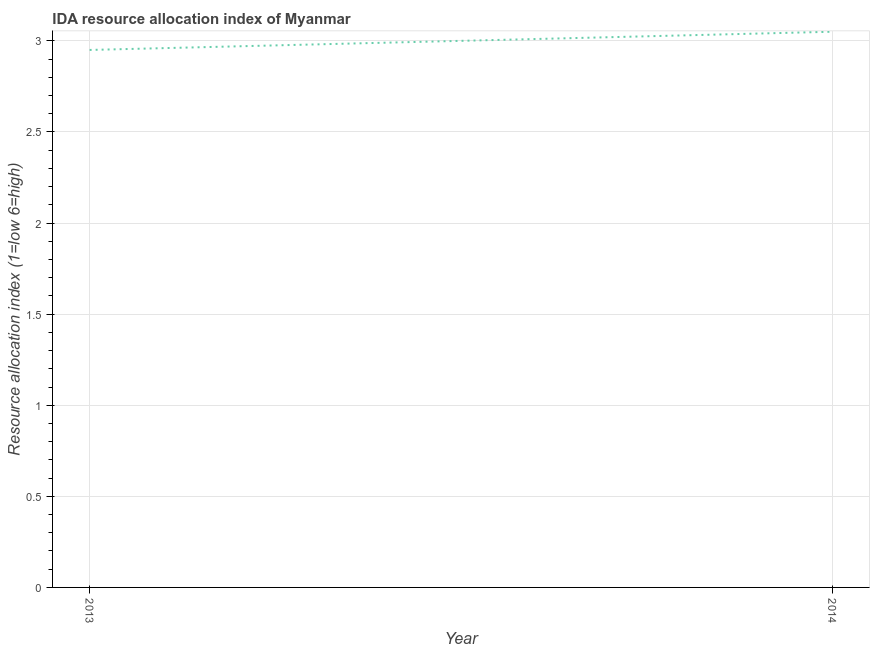What is the ida resource allocation index in 2014?
Ensure brevity in your answer.  3.05. Across all years, what is the maximum ida resource allocation index?
Provide a succinct answer. 3.05. Across all years, what is the minimum ida resource allocation index?
Provide a short and direct response. 2.95. In which year was the ida resource allocation index maximum?
Keep it short and to the point. 2014. What is the sum of the ida resource allocation index?
Your answer should be compact. 6. What is the difference between the ida resource allocation index in 2013 and 2014?
Offer a terse response. -0.1. What is the ratio of the ida resource allocation index in 2013 to that in 2014?
Make the answer very short. 0.97. Is the ida resource allocation index in 2013 less than that in 2014?
Keep it short and to the point. Yes. Does the ida resource allocation index monotonically increase over the years?
Offer a terse response. Yes. How many lines are there?
Make the answer very short. 1. How many years are there in the graph?
Give a very brief answer. 2. What is the difference between two consecutive major ticks on the Y-axis?
Provide a short and direct response. 0.5. Are the values on the major ticks of Y-axis written in scientific E-notation?
Give a very brief answer. No. Does the graph contain any zero values?
Your answer should be very brief. No. Does the graph contain grids?
Make the answer very short. Yes. What is the title of the graph?
Ensure brevity in your answer.  IDA resource allocation index of Myanmar. What is the label or title of the X-axis?
Ensure brevity in your answer.  Year. What is the label or title of the Y-axis?
Your answer should be compact. Resource allocation index (1=low 6=high). What is the Resource allocation index (1=low 6=high) of 2013?
Ensure brevity in your answer.  2.95. What is the Resource allocation index (1=low 6=high) in 2014?
Give a very brief answer. 3.05. What is the difference between the Resource allocation index (1=low 6=high) in 2013 and 2014?
Keep it short and to the point. -0.1. 